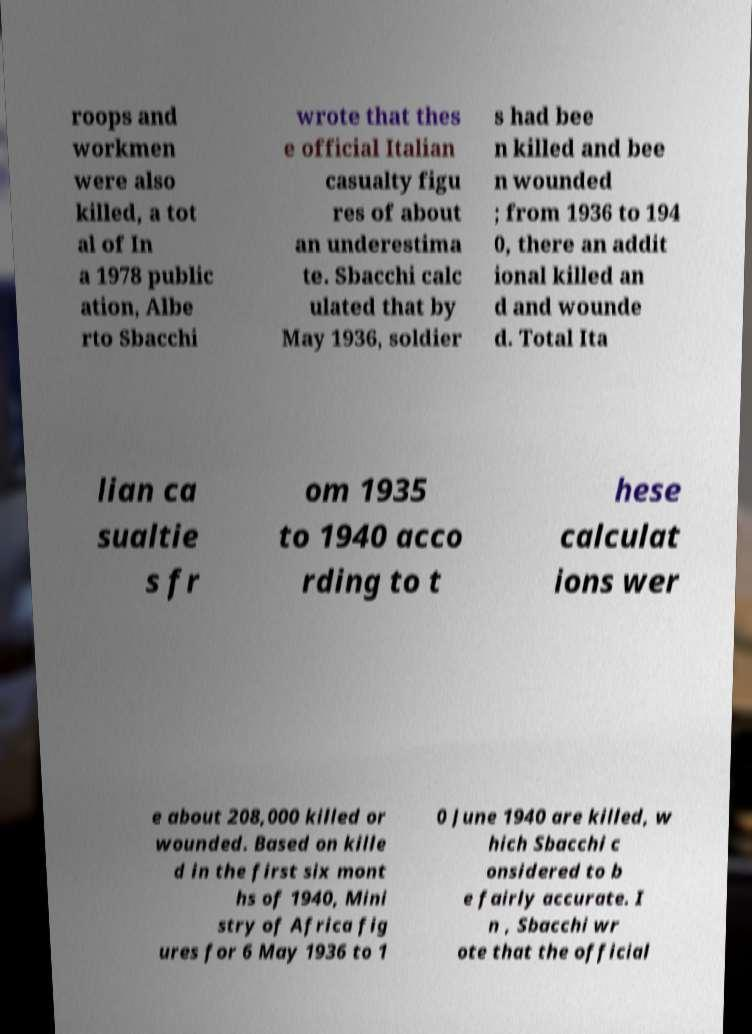Please read and relay the text visible in this image. What does it say? roops and workmen were also killed, a tot al of In a 1978 public ation, Albe rto Sbacchi wrote that thes e official Italian casualty figu res of about an underestima te. Sbacchi calc ulated that by May 1936, soldier s had bee n killed and bee n wounded ; from 1936 to 194 0, there an addit ional killed an d and wounde d. Total Ita lian ca sualtie s fr om 1935 to 1940 acco rding to t hese calculat ions wer e about 208,000 killed or wounded. Based on kille d in the first six mont hs of 1940, Mini stry of Africa fig ures for 6 May 1936 to 1 0 June 1940 are killed, w hich Sbacchi c onsidered to b e fairly accurate. I n , Sbacchi wr ote that the official 